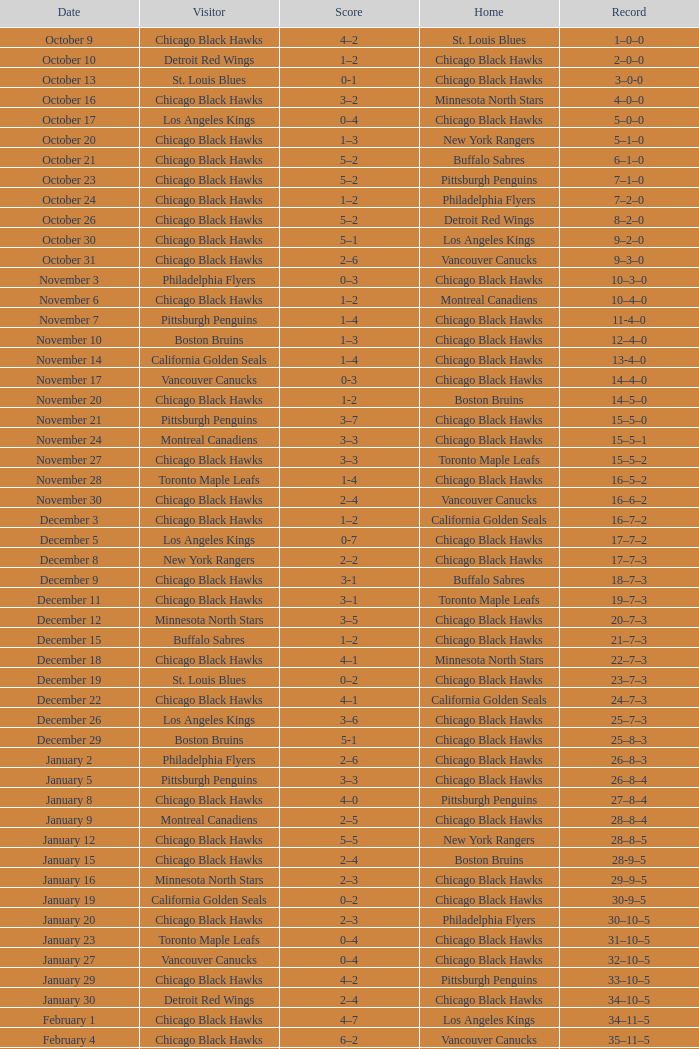What is the Record from February 10? 36–13–5. 